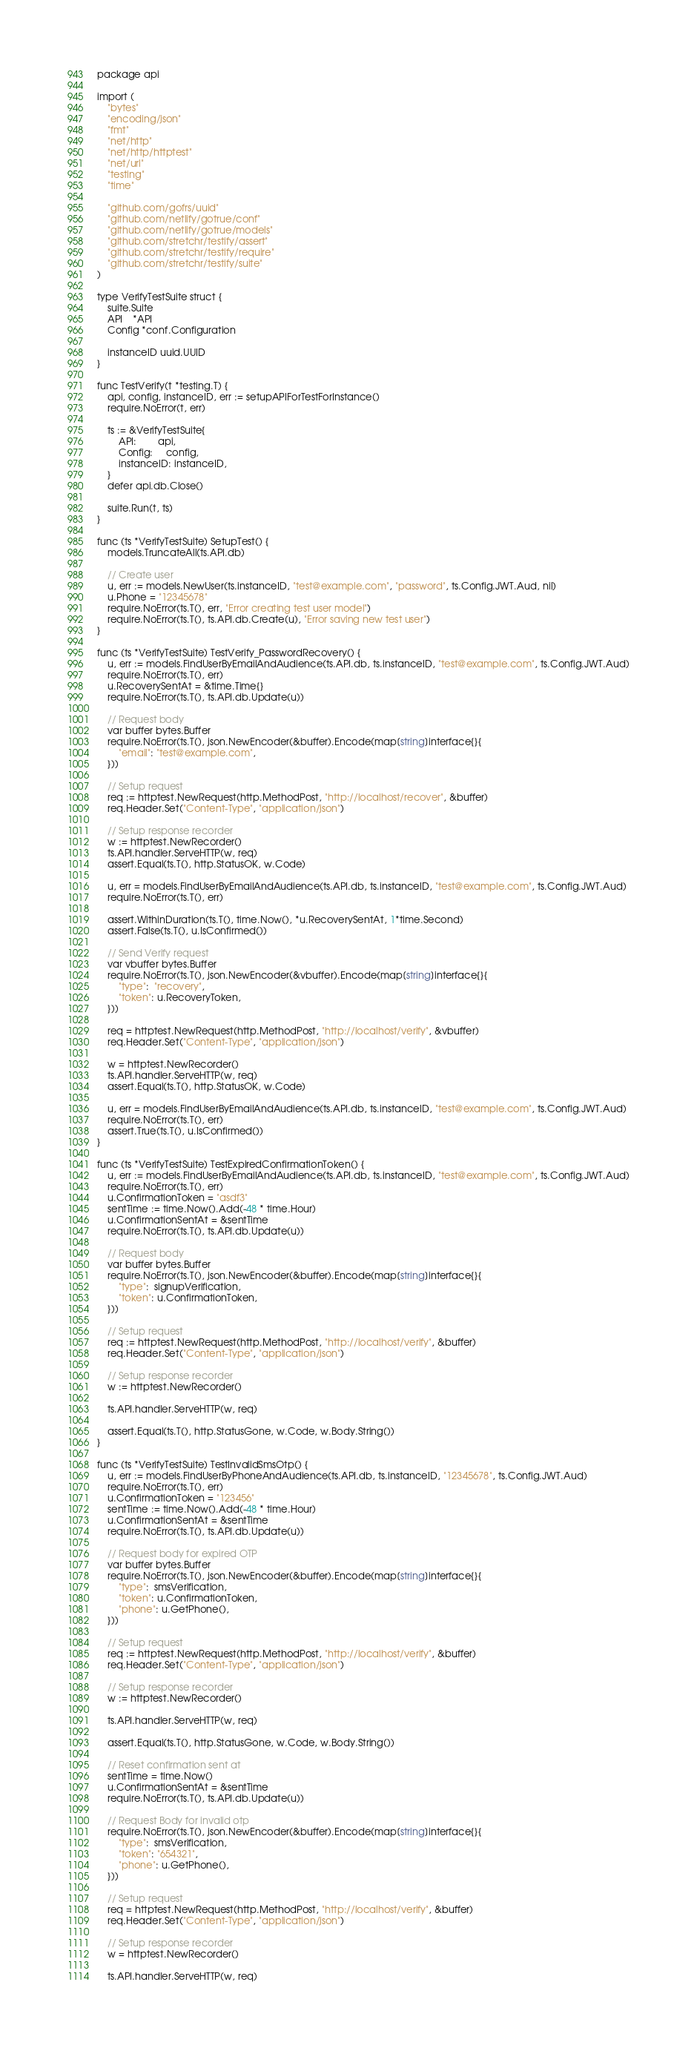<code> <loc_0><loc_0><loc_500><loc_500><_Go_>package api

import (
	"bytes"
	"encoding/json"
	"fmt"
	"net/http"
	"net/http/httptest"
	"net/url"
	"testing"
	"time"

	"github.com/gofrs/uuid"
	"github.com/netlify/gotrue/conf"
	"github.com/netlify/gotrue/models"
	"github.com/stretchr/testify/assert"
	"github.com/stretchr/testify/require"
	"github.com/stretchr/testify/suite"
)

type VerifyTestSuite struct {
	suite.Suite
	API    *API
	Config *conf.Configuration

	instanceID uuid.UUID
}

func TestVerify(t *testing.T) {
	api, config, instanceID, err := setupAPIForTestForInstance()
	require.NoError(t, err)

	ts := &VerifyTestSuite{
		API:        api,
		Config:     config,
		instanceID: instanceID,
	}
	defer api.db.Close()

	suite.Run(t, ts)
}

func (ts *VerifyTestSuite) SetupTest() {
	models.TruncateAll(ts.API.db)

	// Create user
	u, err := models.NewUser(ts.instanceID, "test@example.com", "password", ts.Config.JWT.Aud, nil)
	u.Phone = "12345678"
	require.NoError(ts.T(), err, "Error creating test user model")
	require.NoError(ts.T(), ts.API.db.Create(u), "Error saving new test user")
}

func (ts *VerifyTestSuite) TestVerify_PasswordRecovery() {
	u, err := models.FindUserByEmailAndAudience(ts.API.db, ts.instanceID, "test@example.com", ts.Config.JWT.Aud)
	require.NoError(ts.T(), err)
	u.RecoverySentAt = &time.Time{}
	require.NoError(ts.T(), ts.API.db.Update(u))

	// Request body
	var buffer bytes.Buffer
	require.NoError(ts.T(), json.NewEncoder(&buffer).Encode(map[string]interface{}{
		"email": "test@example.com",
	}))

	// Setup request
	req := httptest.NewRequest(http.MethodPost, "http://localhost/recover", &buffer)
	req.Header.Set("Content-Type", "application/json")

	// Setup response recorder
	w := httptest.NewRecorder()
	ts.API.handler.ServeHTTP(w, req)
	assert.Equal(ts.T(), http.StatusOK, w.Code)

	u, err = models.FindUserByEmailAndAudience(ts.API.db, ts.instanceID, "test@example.com", ts.Config.JWT.Aud)
	require.NoError(ts.T(), err)

	assert.WithinDuration(ts.T(), time.Now(), *u.RecoverySentAt, 1*time.Second)
	assert.False(ts.T(), u.IsConfirmed())

	// Send Verify request
	var vbuffer bytes.Buffer
	require.NoError(ts.T(), json.NewEncoder(&vbuffer).Encode(map[string]interface{}{
		"type":  "recovery",
		"token": u.RecoveryToken,
	}))

	req = httptest.NewRequest(http.MethodPost, "http://localhost/verify", &vbuffer)
	req.Header.Set("Content-Type", "application/json")

	w = httptest.NewRecorder()
	ts.API.handler.ServeHTTP(w, req)
	assert.Equal(ts.T(), http.StatusOK, w.Code)

	u, err = models.FindUserByEmailAndAudience(ts.API.db, ts.instanceID, "test@example.com", ts.Config.JWT.Aud)
	require.NoError(ts.T(), err)
	assert.True(ts.T(), u.IsConfirmed())
}

func (ts *VerifyTestSuite) TestExpiredConfirmationToken() {
	u, err := models.FindUserByEmailAndAudience(ts.API.db, ts.instanceID, "test@example.com", ts.Config.JWT.Aud)
	require.NoError(ts.T(), err)
	u.ConfirmationToken = "asdf3"
	sentTime := time.Now().Add(-48 * time.Hour)
	u.ConfirmationSentAt = &sentTime
	require.NoError(ts.T(), ts.API.db.Update(u))

	// Request body
	var buffer bytes.Buffer
	require.NoError(ts.T(), json.NewEncoder(&buffer).Encode(map[string]interface{}{
		"type":  signupVerification,
		"token": u.ConfirmationToken,
	}))

	// Setup request
	req := httptest.NewRequest(http.MethodPost, "http://localhost/verify", &buffer)
	req.Header.Set("Content-Type", "application/json")

	// Setup response recorder
	w := httptest.NewRecorder()

	ts.API.handler.ServeHTTP(w, req)

	assert.Equal(ts.T(), http.StatusGone, w.Code, w.Body.String())
}

func (ts *VerifyTestSuite) TestInvalidSmsOtp() {
	u, err := models.FindUserByPhoneAndAudience(ts.API.db, ts.instanceID, "12345678", ts.Config.JWT.Aud)
	require.NoError(ts.T(), err)
	u.ConfirmationToken = "123456"
	sentTime := time.Now().Add(-48 * time.Hour)
	u.ConfirmationSentAt = &sentTime
	require.NoError(ts.T(), ts.API.db.Update(u))

	// Request body for expired OTP
	var buffer bytes.Buffer
	require.NoError(ts.T(), json.NewEncoder(&buffer).Encode(map[string]interface{}{
		"type":  smsVerification,
		"token": u.ConfirmationToken,
		"phone": u.GetPhone(),
	}))

	// Setup request
	req := httptest.NewRequest(http.MethodPost, "http://localhost/verify", &buffer)
	req.Header.Set("Content-Type", "application/json")

	// Setup response recorder
	w := httptest.NewRecorder()

	ts.API.handler.ServeHTTP(w, req)

	assert.Equal(ts.T(), http.StatusGone, w.Code, w.Body.String())

	// Reset confirmation sent at
	sentTime = time.Now()
	u.ConfirmationSentAt = &sentTime
	require.NoError(ts.T(), ts.API.db.Update(u))

	// Request Body for invalid otp
	require.NoError(ts.T(), json.NewEncoder(&buffer).Encode(map[string]interface{}{
		"type":  smsVerification,
		"token": "654321",
		"phone": u.GetPhone(),
	}))

	// Setup request
	req = httptest.NewRequest(http.MethodPost, "http://localhost/verify", &buffer)
	req.Header.Set("Content-Type", "application/json")

	// Setup response recorder
	w = httptest.NewRecorder()

	ts.API.handler.ServeHTTP(w, req)
</code> 